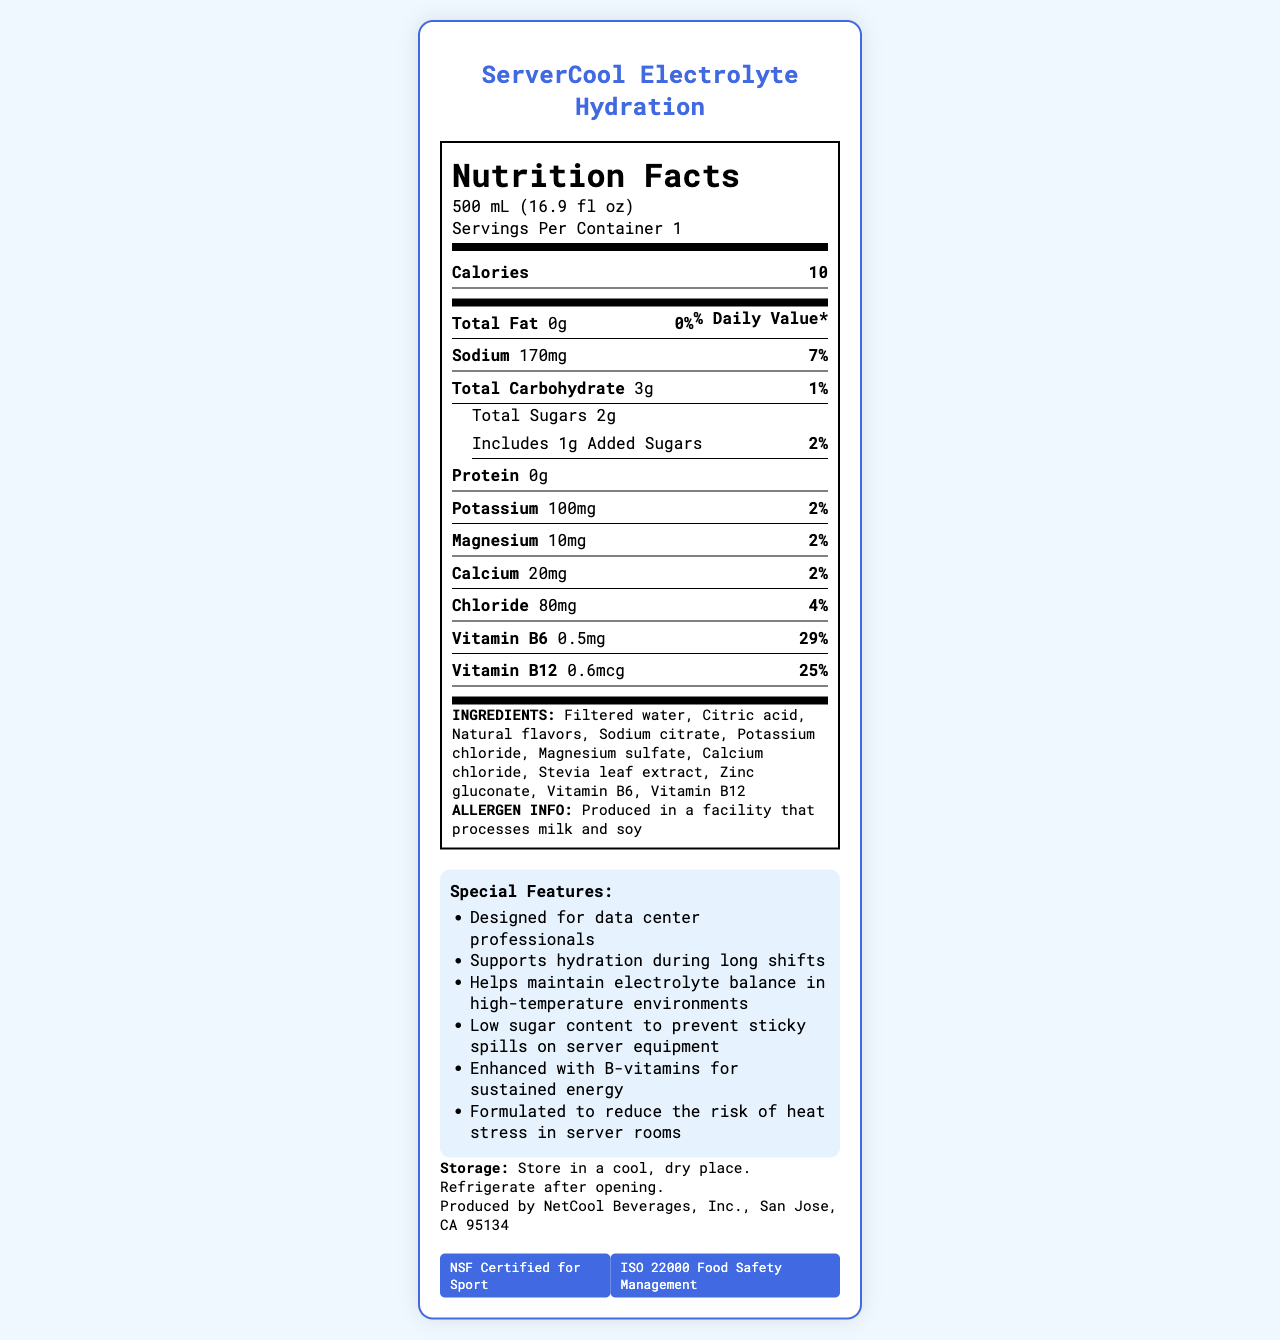What is the serving size? The serving size is clearly stated in the Nutrition Facts section of the document.
Answer: 500 mL (16.9 fl oz) How much sodium does one serving contain? In the Nutrition Facts section, sodium content per serving is listed as 170mg.
Answer: 170mg What percentage of the daily value is provided by the Vitamin B6? The document indicates that Vitamin B6 provides 29% of the daily value per serving.
Answer: 29% List three main ingredients of ServerCool Electrolyte Hydration. The main ingredients are listed at the bottom of the Nutrition Facts label under the INGREDIENTS section.
Answer: Filtered water, Citric acid, Natural flavors How many calories are in one serving? The calorie content per serving is clearly stated as 10 in the label.
Answer: 10 What are two key certifications mentioned? The certifications are listed towards the bottom of the document under CERTIFICATIONS.
Answer: NSF Certified for Sport, ISO 22000 Food Safety Management Which of the following is a special feature of ServerCool Electrolyte Hydration? A. High sugar content B. Low sugar content to prevent sticky spills C. No added vitamins One of the special features listed in the document is "Low sugar content to prevent sticky spills on server equipment".
Answer: B How much potassium does one serving contain? A. 50mg B. 80mg C. 100mg The document lists potassium content as 100mg per serving in the Nutrition Facts section.
Answer: C Is the product NSF Certified for Sport? The certification information at the bottom of the document confirms that the product is NSF Certified for Sport.
Answer: Yes Summarize the main purpose of the ServerCool Electrolyte Hydration document. This summary captures the various sections of the document, including the purpose, nutritional content, certifications, and special features tailored to data center professionals.
Answer: The document provides detailed nutritional information about ServerCool Electrolyte Hydration, an electrolyte-enhanced water designed to support hydration for data center professionals working in high-temperature environments. It lists ingredients, allergens, nutritional content, certifications, and special features such as low sugar content and added B-vitamins for sustained energy. Who is the manufacturer of this product? The manufacturer information at the bottom of the document states that the product is produced by NetCool Beverages, Inc.
Answer: NetCool Beverages, Inc. What are the storage instructions for the product? The storage instructions are provided towards the bottom of the document.
Answer: Store in a cool, dry place. Refrigerate after opening. How much chloride does one serving contain? The Nutrition Facts section lists chloride content as 80mg per serving.
Answer: 80mg Does the product contain any protein? The document states there are 0g of protein in one serving.
Answer: No What is the exact amount of Vitamin B12 per serving? The Nutrition Facts section lists the exact amount as 0.6mcg per serving.
Answer: 0.6mcg What's the unique feature of this product for use in server rooms? Among the special features, it is noted that the product is formulated to reduce the risk of heat stress in server rooms.
Answer: Formulated to reduce the risk of heat stress in server rooms How many grams of total sugars are there? According to the Nutrition Facts section, the total sugars per serving are 2g.
Answer: 2g What is the daily value percentage of magnesium? The daily value percentage of magnesium is listed as 2% in the Nutrition Facts section.
Answer: 2% Which of the following allergens might be processed in the facility where this drink is produced? A. Gluten B. Milk and soy C. Nuts and seeds The allergen information states that the product is produced in a facility that processes milk and soy.
Answer: B What benefit does the product claim to provide in relation to high-temperature environments? One of the special features listed is maintaining electrolyte balance in high-temperature environments.
Answer: Helps maintain electrolyte balance in high-temperature environments Can we determine the flavor of ServerCool Electrolyte Hydration from the document? The document does not specify any particular flavor, only "Natural flavors" in the ingredients list without further detail.
Answer: Not enough information 